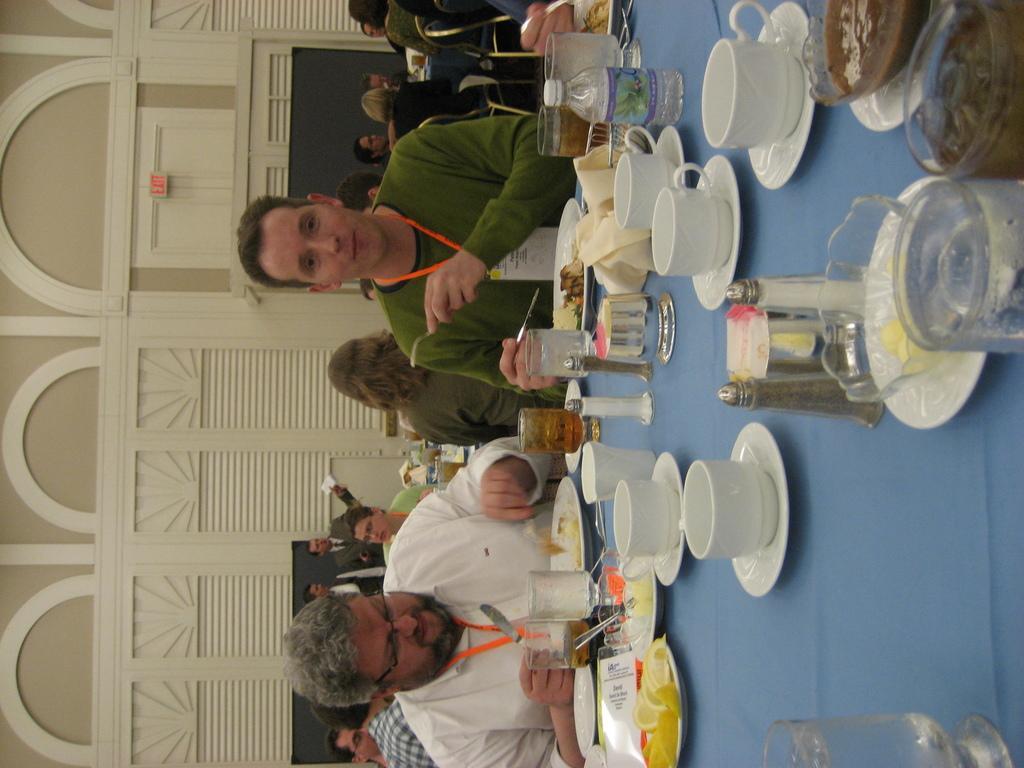Can you describe this image briefly? There is a table on which there are cups, saucers, bottle, bowls and food items. 2 people are sitting wearing white shirt, green shirt and id cards. Behind them there are other people. 